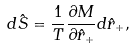Convert formula to latex. <formula><loc_0><loc_0><loc_500><loc_500>d \hat { S } = \frac { 1 } { T } \frac { \partial M } { \partial \hat { r } _ { + } } d \hat { r } _ { + } ,</formula> 